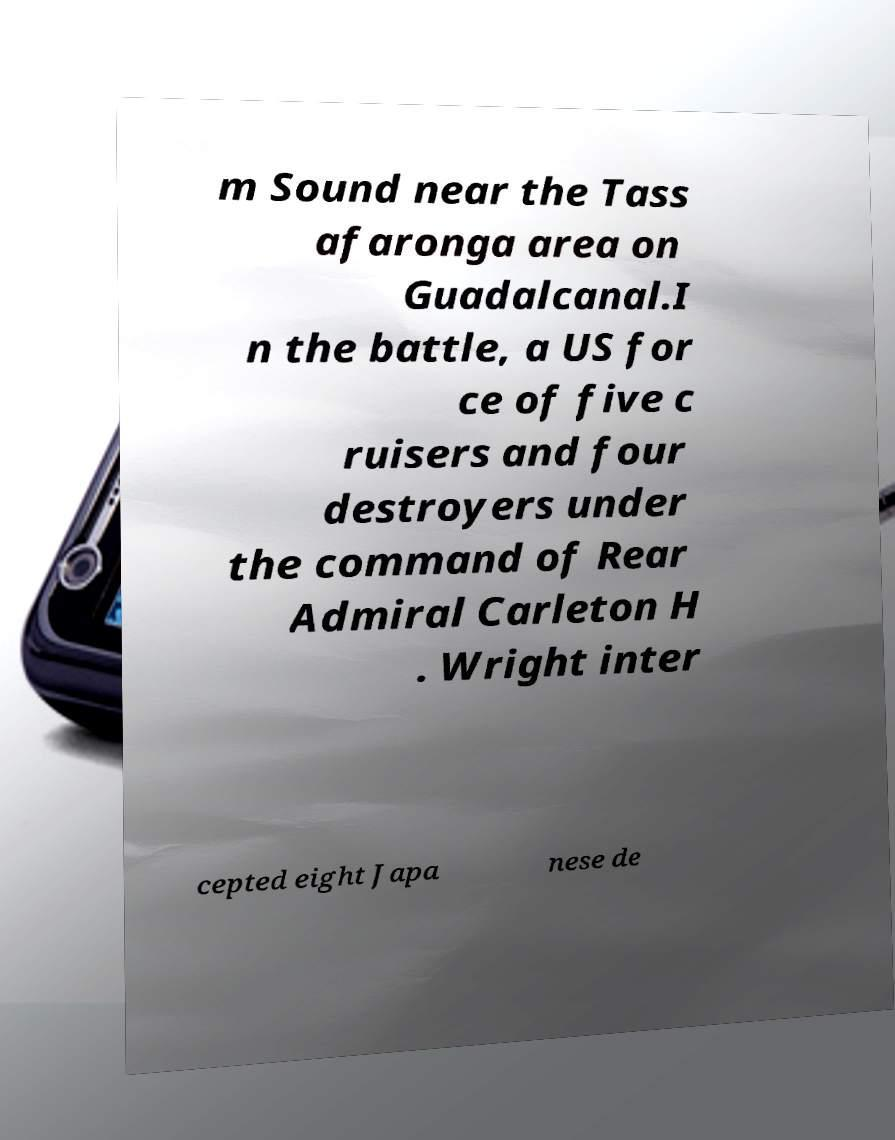Could you extract and type out the text from this image? m Sound near the Tass afaronga area on Guadalcanal.I n the battle, a US for ce of five c ruisers and four destroyers under the command of Rear Admiral Carleton H . Wright inter cepted eight Japa nese de 